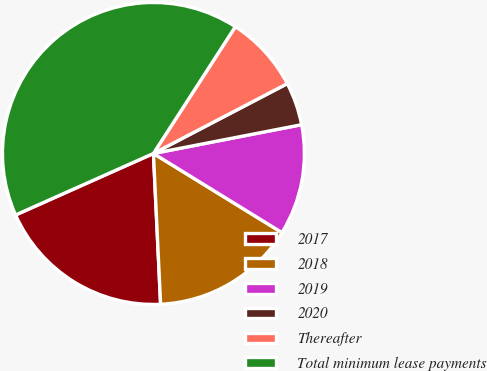Convert chart. <chart><loc_0><loc_0><loc_500><loc_500><pie_chart><fcel>2017<fcel>2018<fcel>2019<fcel>2020<fcel>Thereafter<fcel>Total minimum lease payments<nl><fcel>19.08%<fcel>15.46%<fcel>11.84%<fcel>4.6%<fcel>8.22%<fcel>40.81%<nl></chart> 